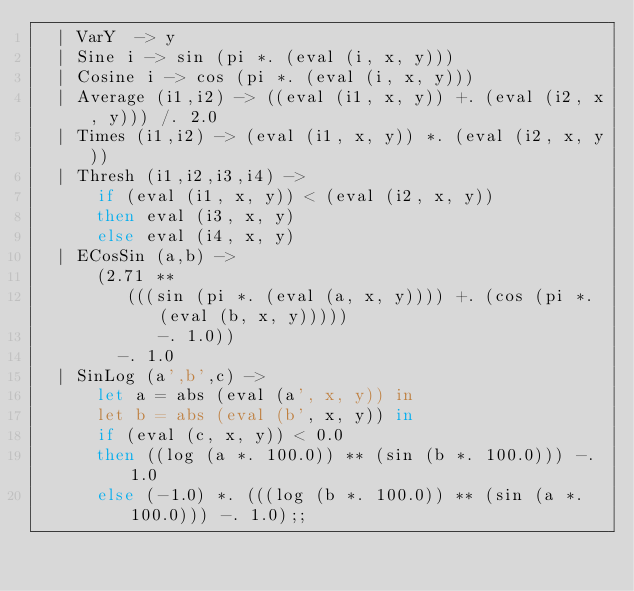Convert code to text. <code><loc_0><loc_0><loc_500><loc_500><_OCaml_>  | VarY  -> y
  | Sine i -> sin (pi *. (eval (i, x, y)))
  | Cosine i -> cos (pi *. (eval (i, x, y)))
  | Average (i1,i2) -> ((eval (i1, x, y)) +. (eval (i2, x, y))) /. 2.0
  | Times (i1,i2) -> (eval (i1, x, y)) *. (eval (i2, x, y))
  | Thresh (i1,i2,i3,i4) ->
      if (eval (i1, x, y)) < (eval (i2, x, y))
      then eval (i3, x, y)
      else eval (i4, x, y)
  | ECosSin (a,b) ->
      (2.71 **
         (((sin (pi *. (eval (a, x, y)))) +. (cos (pi *. (eval (b, x, y)))))
            -. 1.0))
        -. 1.0
  | SinLog (a',b',c) ->
      let a = abs (eval (a', x, y)) in
      let b = abs (eval (b', x, y)) in
      if (eval (c, x, y)) < 0.0
      then ((log (a *. 100.0)) ** (sin (b *. 100.0))) -. 1.0
      else (-1.0) *. (((log (b *. 100.0)) ** (sin (a *. 100.0))) -. 1.0);;
</code> 